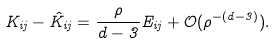<formula> <loc_0><loc_0><loc_500><loc_500>K _ { i j } - \hat { K } _ { i j } = \frac { \rho } { d - 3 } E _ { i j } + \mathcal { O } ( \rho ^ { - ( d - 3 ) } ) .</formula> 